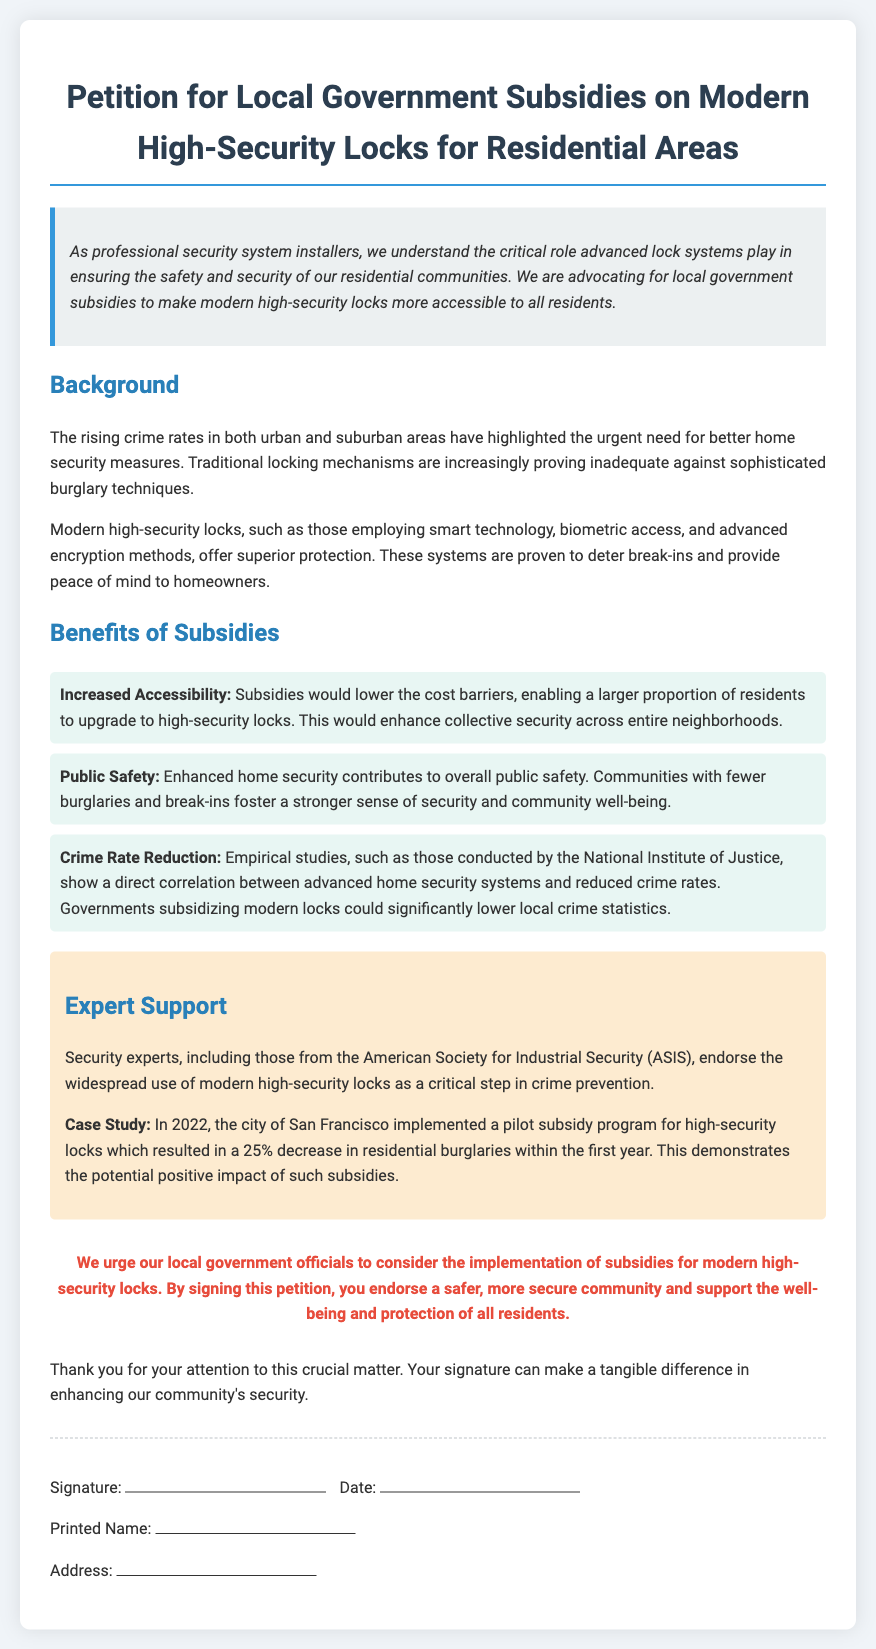What is the title of the petition? The title of the petition is stated at the top of the document.
Answer: Petition for Local Government Subsidies on Modern High-Security Locks for Residential Areas What year did the case study take place? The case study mentioned in the petition refers to events in a specific year.
Answer: 2022 What organization endorsed the use of modern high-security locks? The document provides the name of the organization that supports the initiative.
Answer: American Society for Industrial Security (ASIS) What percentage decrease in burglaries was recorded in the case study? The petition highlights the impact of a subsidy program on burglary rates, providing a specific percentage.
Answer: 25% What does the introduction emphasize regarding lock systems? The introduction discusses the importance of lock systems in relation to community safety and security.
Answer: Critical role What is the purpose of the subsidies mentioned? The petition outlines the intended goal of the subsidies for high-security locks.
Answer: Increase accessibility What is one benefit of enhanced home security stated in the document? The document lists benefits of improved home security measures to the public.
Answer: Public Safety What type of technology do modern high-security locks employ? The petition briefly mentions the technologies involved in modern high-security locks.
Answer: Smart technology What action does the petition urge local government officials to take? The document conveys a clear call to action for local officials.
Answer: Implement subsidies 